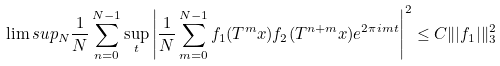Convert formula to latex. <formula><loc_0><loc_0><loc_500><loc_500>\lim s u p _ { N } \frac { 1 } { N } \sum _ { n = 0 } ^ { N - 1 } \sup _ { t } \left | \frac { 1 } { N } \sum _ { m = 0 } ^ { N - 1 } f _ { 1 } ( T ^ { m } x ) f _ { 2 } ( T ^ { n + m } x ) e ^ { 2 \pi i m t } \right | ^ { 2 } \leq C \| | f _ { 1 } | \| _ { 3 } ^ { 2 }</formula> 